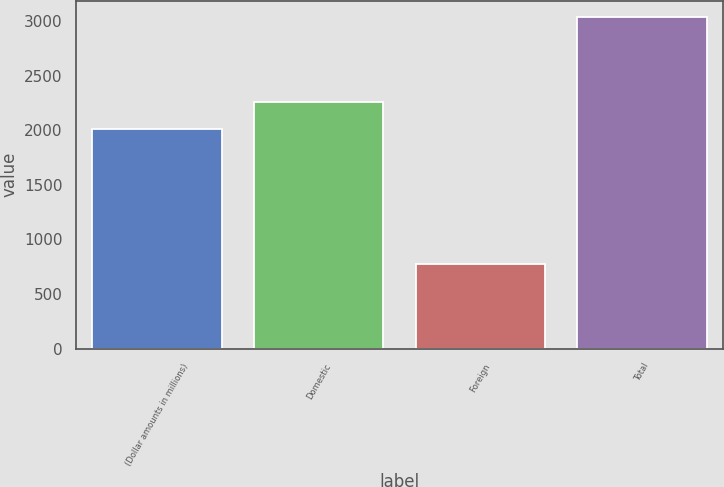Convert chart to OTSL. <chart><loc_0><loc_0><loc_500><loc_500><bar_chart><fcel>(Dollar amounts in millions)<fcel>Domestic<fcel>Foreign<fcel>Total<nl><fcel>2010<fcel>2258<fcel>776<fcel>3034<nl></chart> 